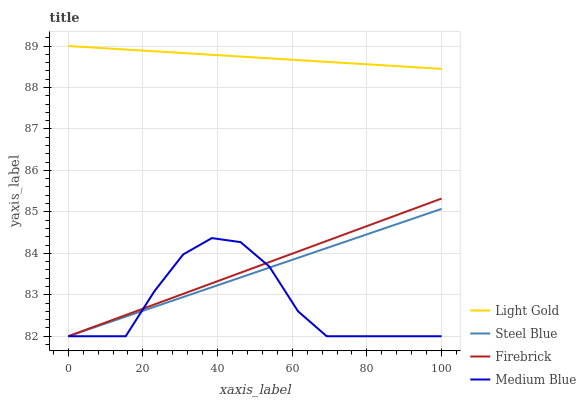Does Medium Blue have the minimum area under the curve?
Answer yes or no. Yes. Does Light Gold have the maximum area under the curve?
Answer yes or no. Yes. Does Firebrick have the minimum area under the curve?
Answer yes or no. No. Does Firebrick have the maximum area under the curve?
Answer yes or no. No. Is Steel Blue the smoothest?
Answer yes or no. Yes. Is Medium Blue the roughest?
Answer yes or no. Yes. Is Firebrick the smoothest?
Answer yes or no. No. Is Firebrick the roughest?
Answer yes or no. No. Does Light Gold have the lowest value?
Answer yes or no. No. Does Firebrick have the highest value?
Answer yes or no. No. Is Steel Blue less than Light Gold?
Answer yes or no. Yes. Is Light Gold greater than Steel Blue?
Answer yes or no. Yes. Does Steel Blue intersect Light Gold?
Answer yes or no. No. 